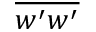Convert formula to latex. <formula><loc_0><loc_0><loc_500><loc_500>\overline { { w ^ { \prime } w ^ { \prime } } }</formula> 